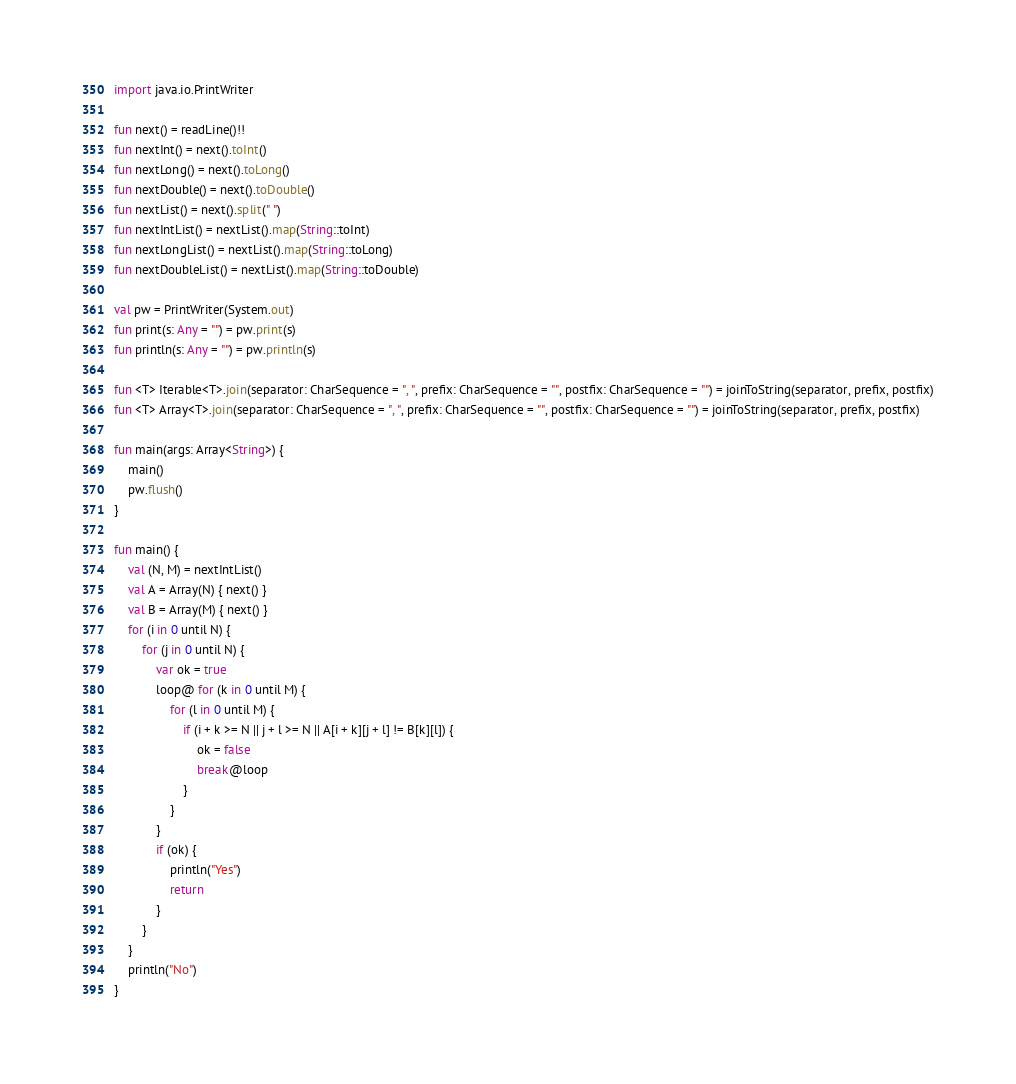Convert code to text. <code><loc_0><loc_0><loc_500><loc_500><_Kotlin_>import java.io.PrintWriter

fun next() = readLine()!!
fun nextInt() = next().toInt()
fun nextLong() = next().toLong()
fun nextDouble() = next().toDouble()
fun nextList() = next().split(" ")
fun nextIntList() = nextList().map(String::toInt)
fun nextLongList() = nextList().map(String::toLong)
fun nextDoubleList() = nextList().map(String::toDouble)

val pw = PrintWriter(System.out)
fun print(s: Any = "") = pw.print(s)
fun println(s: Any = "") = pw.println(s)

fun <T> Iterable<T>.join(separator: CharSequence = ", ", prefix: CharSequence = "", postfix: CharSequence = "") = joinToString(separator, prefix, postfix)
fun <T> Array<T>.join(separator: CharSequence = ", ", prefix: CharSequence = "", postfix: CharSequence = "") = joinToString(separator, prefix, postfix)

fun main(args: Array<String>) {
    main()
    pw.flush()
}

fun main() {
    val (N, M) = nextIntList()
    val A = Array(N) { next() }
    val B = Array(M) { next() }
    for (i in 0 until N) {
        for (j in 0 until N) {
            var ok = true
            loop@ for (k in 0 until M) {
                for (l in 0 until M) {
                    if (i + k >= N || j + l >= N || A[i + k][j + l] != B[k][l]) {
                        ok = false
                        break@loop
                    }
                }
            }
            if (ok) {
                println("Yes")
                return
            }
        }
    }
    println("No")
}</code> 